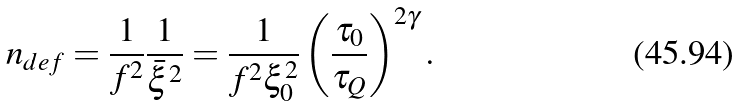<formula> <loc_0><loc_0><loc_500><loc_500>n _ { d e f } = \frac { 1 } { f ^ { 2 } } \frac { 1 } { { \bar { \xi } } ^ { 2 } } = \frac { 1 } { f ^ { 2 } \xi _ { 0 } ^ { 2 } } \left ( \frac { \tau _ { 0 } } { \tau _ { Q } } \right ) ^ { 2 \gamma } .</formula> 